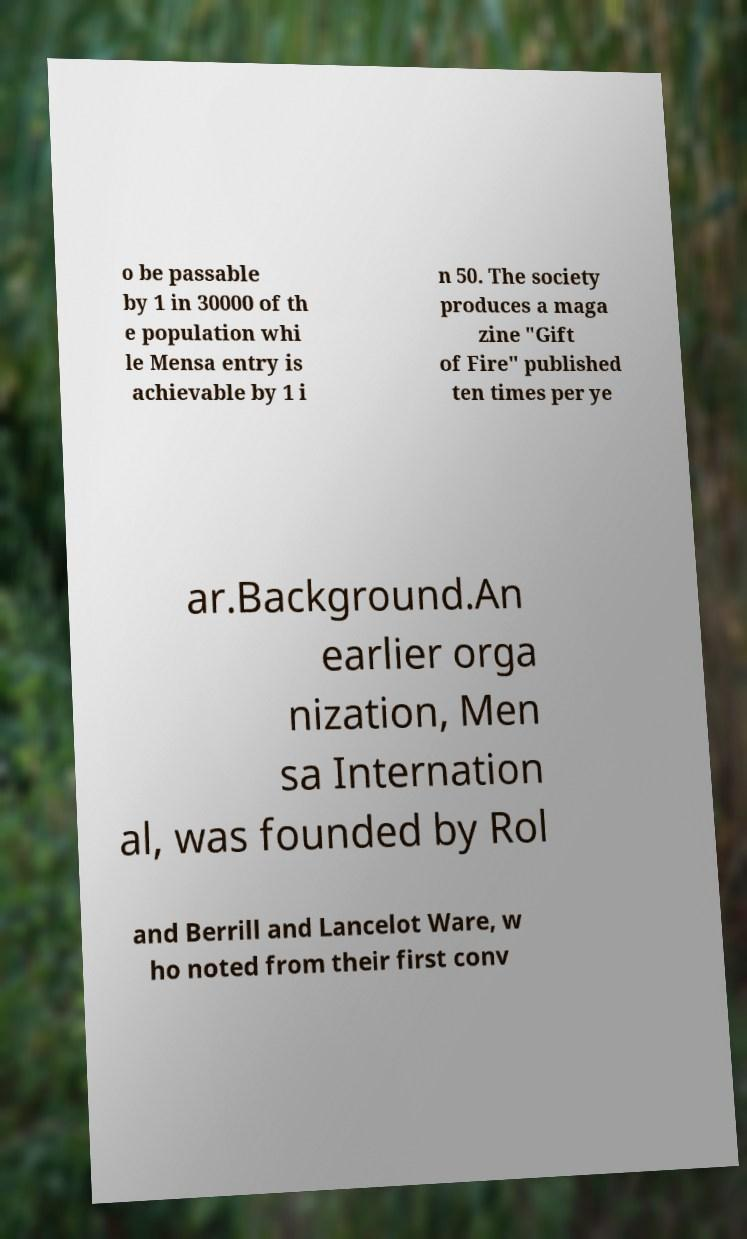There's text embedded in this image that I need extracted. Can you transcribe it verbatim? o be passable by 1 in 30000 of th e population whi le Mensa entry is achievable by 1 i n 50. The society produces a maga zine "Gift of Fire" published ten times per ye ar.Background.An earlier orga nization, Men sa Internation al, was founded by Rol and Berrill and Lancelot Ware, w ho noted from their first conv 